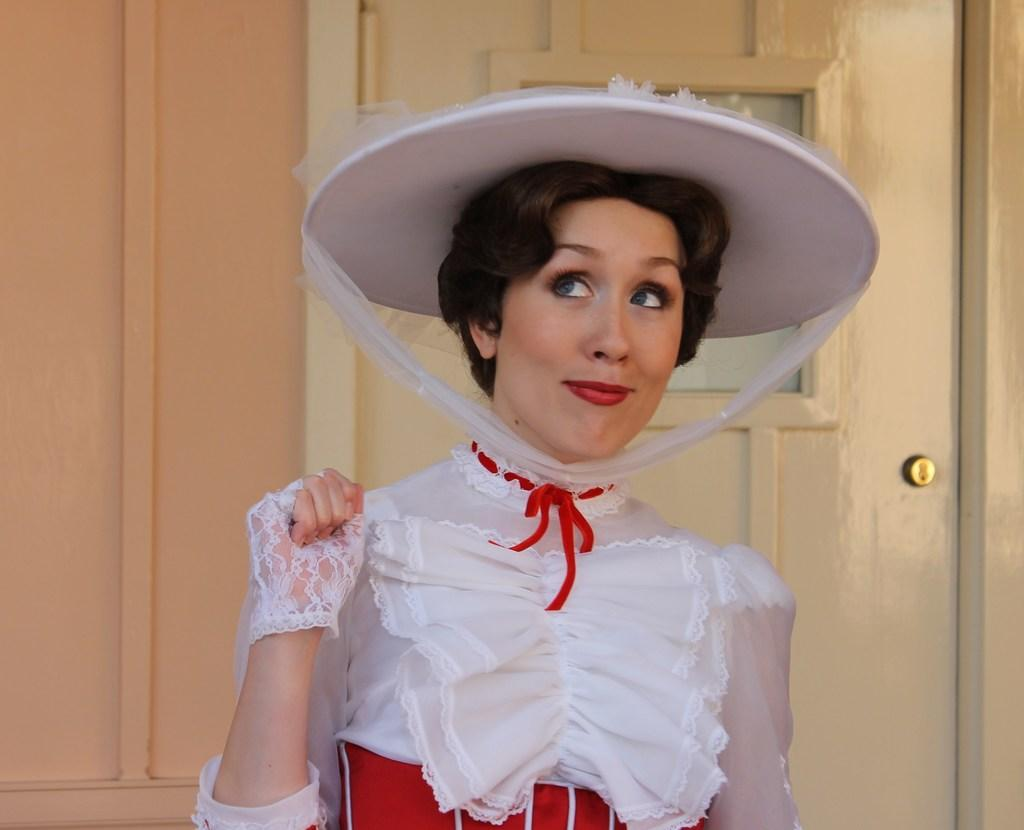What is the main subject of the image? The main subject of the image is a lady person. What is the lady person wearing? The lady person is wearing a white and red color dress and a white color hat. What is the lady person's facial expression? The lady person is smiling. What can be seen in the background of the image? There is a wall and a door in the background of the image. What type of government is depicted in the image? There is no depiction of a government in the image; it features a lady person wearing a white and red color dress, a white color hat, and smiling. 